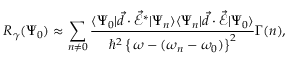Convert formula to latex. <formula><loc_0><loc_0><loc_500><loc_500>R _ { \gamma } ( \Psi _ { 0 } ) \approx \sum _ { n \neq 0 } \frac { \langle \Psi _ { 0 } | \vec { d } \cdot \vec { \mathcal { E } } ^ { * } | \Psi _ { n } \rangle \langle \Psi _ { n } | \vec { d } \cdot \vec { \mathcal { E } } | \Psi _ { 0 } \rangle } { \hbar { ^ } { 2 } \left \{ \, \omega - ( \omega _ { n } - \omega _ { 0 } ) \right \} ^ { 2 } } \Gamma ( n ) ,</formula> 